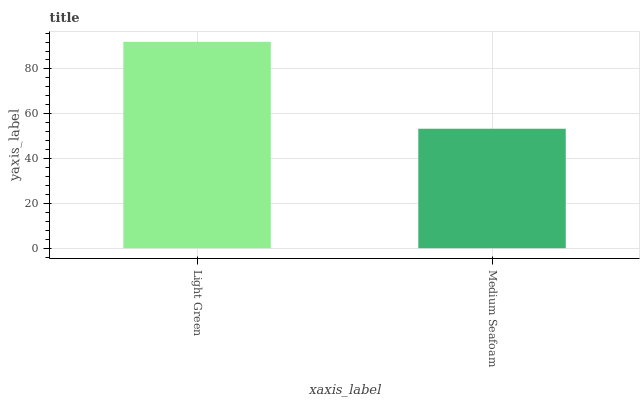Is Medium Seafoam the minimum?
Answer yes or no. Yes. Is Light Green the maximum?
Answer yes or no. Yes. Is Medium Seafoam the maximum?
Answer yes or no. No. Is Light Green greater than Medium Seafoam?
Answer yes or no. Yes. Is Medium Seafoam less than Light Green?
Answer yes or no. Yes. Is Medium Seafoam greater than Light Green?
Answer yes or no. No. Is Light Green less than Medium Seafoam?
Answer yes or no. No. Is Light Green the high median?
Answer yes or no. Yes. Is Medium Seafoam the low median?
Answer yes or no. Yes. Is Medium Seafoam the high median?
Answer yes or no. No. Is Light Green the low median?
Answer yes or no. No. 